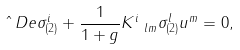<formula> <loc_0><loc_0><loc_500><loc_500>\hat { \ } D e \sigma ^ { i } _ { ( 2 ) } + \frac { 1 } { 1 + g } K ^ { i } _ { \ l m } \sigma ^ { l } _ { ( 2 ) } u ^ { m } = 0 ,</formula> 